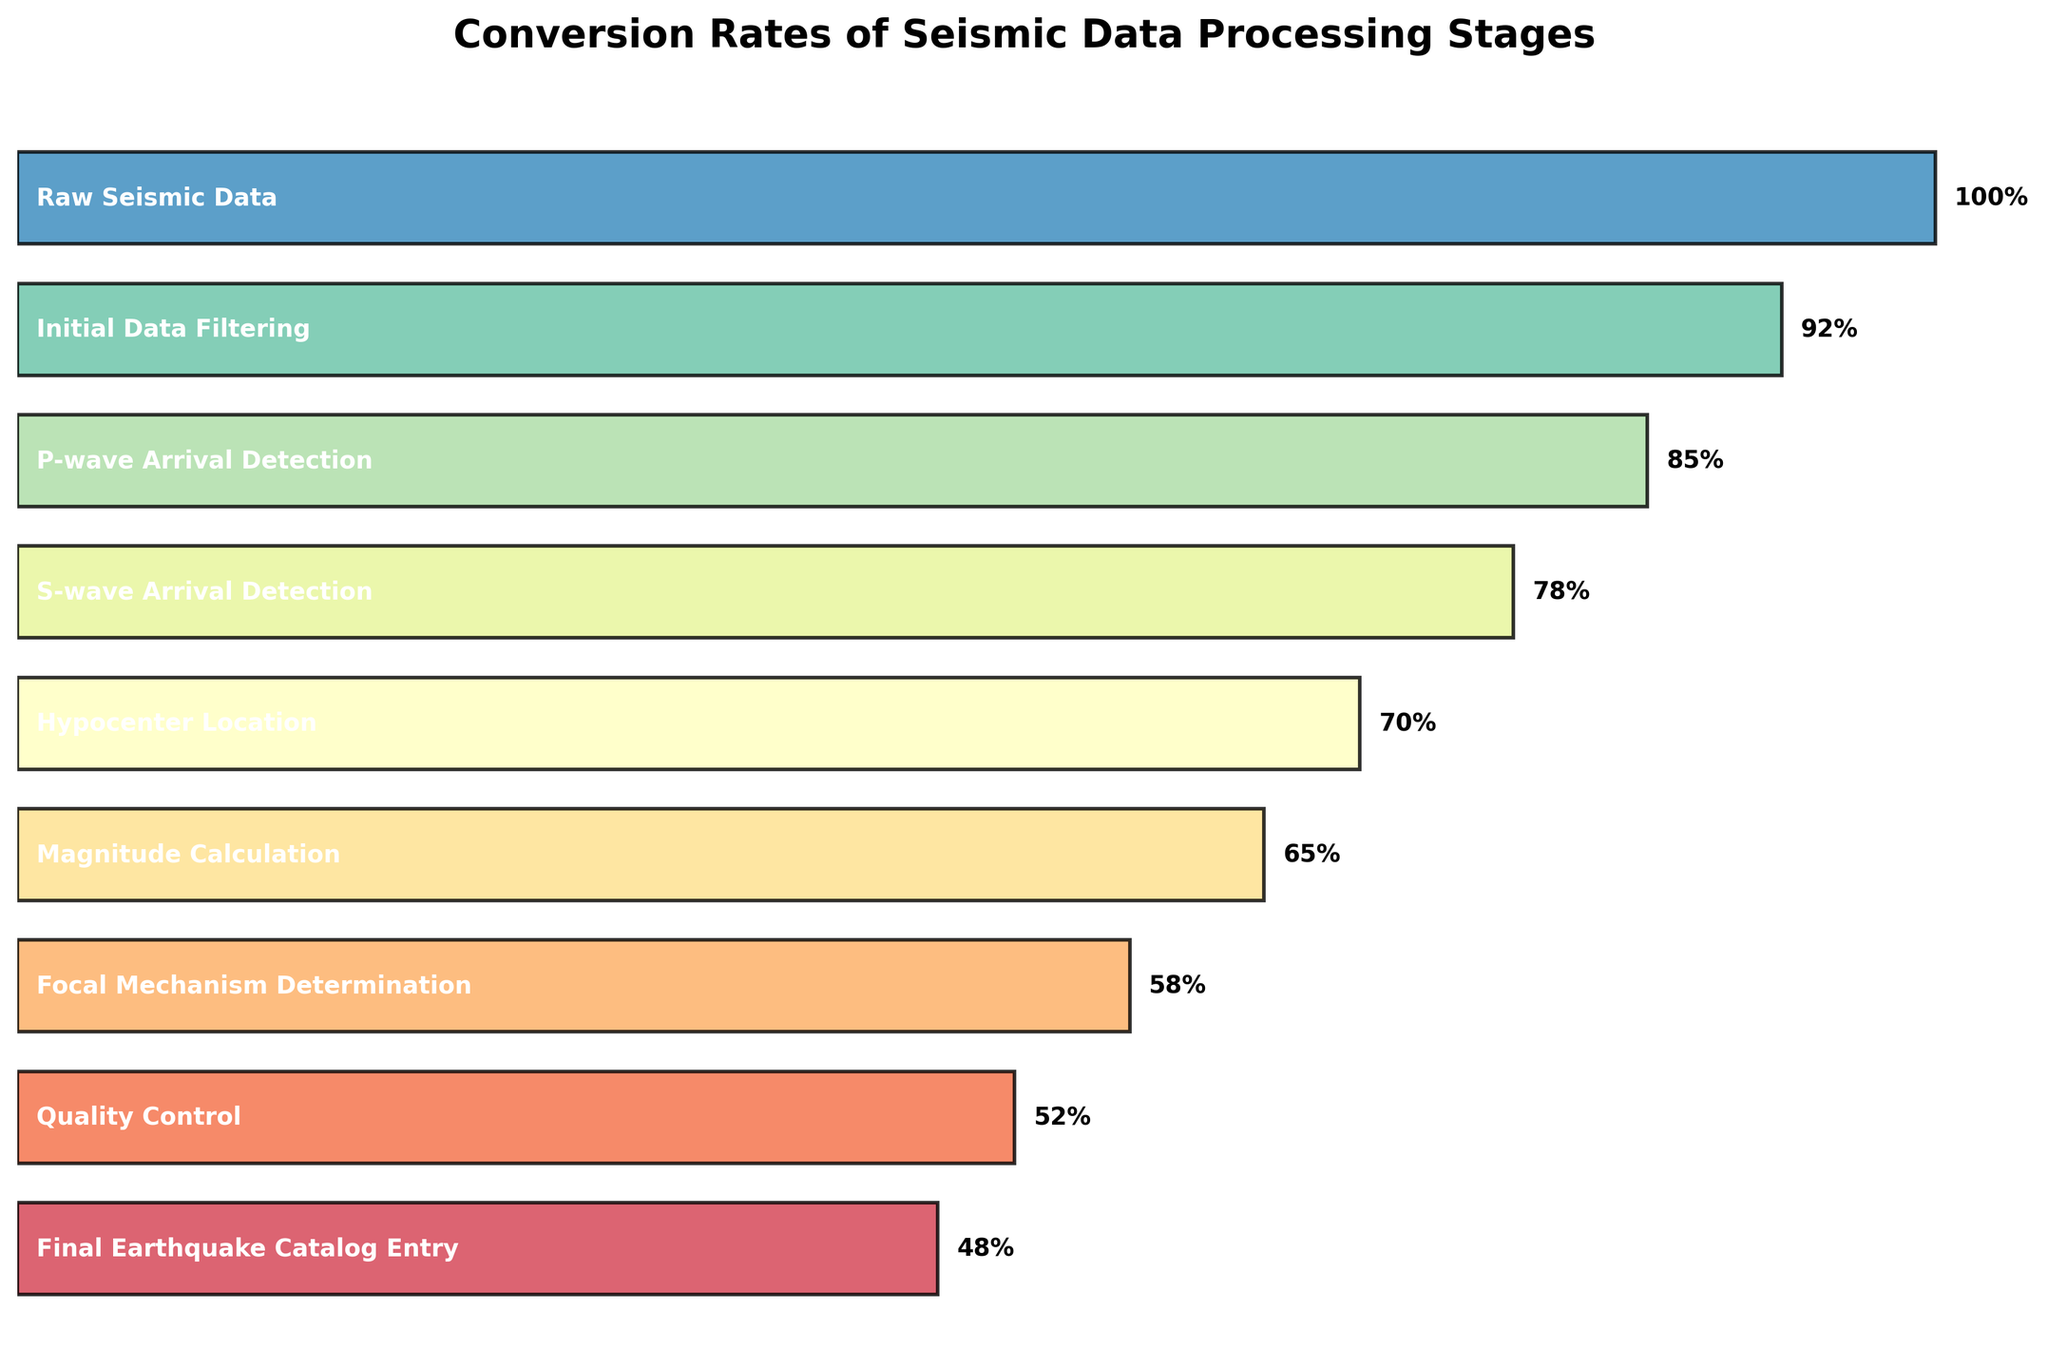How many stages are presented in the flow chart? Count the number of bars representing each stage.
Answer: 9 Which stage has the highest conversion rate? Identify the bar with the maximum length, as it represents the highest conversion rate.
Answer: Raw Seismic Data Which stage has the lowest conversion rate? Identify the bar with the minimum length, as it represents the lowest conversion rate.
Answer: Final Earthquake Catalog Entry What is the difference in conversion rate between Raw Seismic Data and Final Earthquake Catalog Entry? Subtract the conversion rate of the Final Earthquake Catalog Entry from that of the Raw Seismic Data (100 - 48).
Answer: 52 What percentage of data is filtered out after Initial Data Filtering? Subtract the conversion rate of Initial Data Filtering from that of Raw Seismic Data (100 - 92).
Answer: 8% How many stages have a conversion rate below 80? Identify and count the bars with a conversion rate less than 80.
Answer: 5 Is the conversion rate for Magnitude Calculation greater than that for Hypocenter Location? Compare the lengths of the bars for Magnitude Calculation and Hypocenter Location.
Answer: No What is the cumulative conversion rate loss from Raw Seismic Data to S-wave Arrival Detection? Subtract the conversion rate of S-wave Arrival Detection from that of Raw Seismic Data (100 - 78).
Answer: 22 Which stage sees a reduction of 7% in conversion rate? Identify the stage that has a reduction of 7% in its conversion rate compared to the previous stage. This is between Initial Data Filtering (92%) and P-wave Arrival Detection (85%).
Answer: P-wave Arrival Detection 